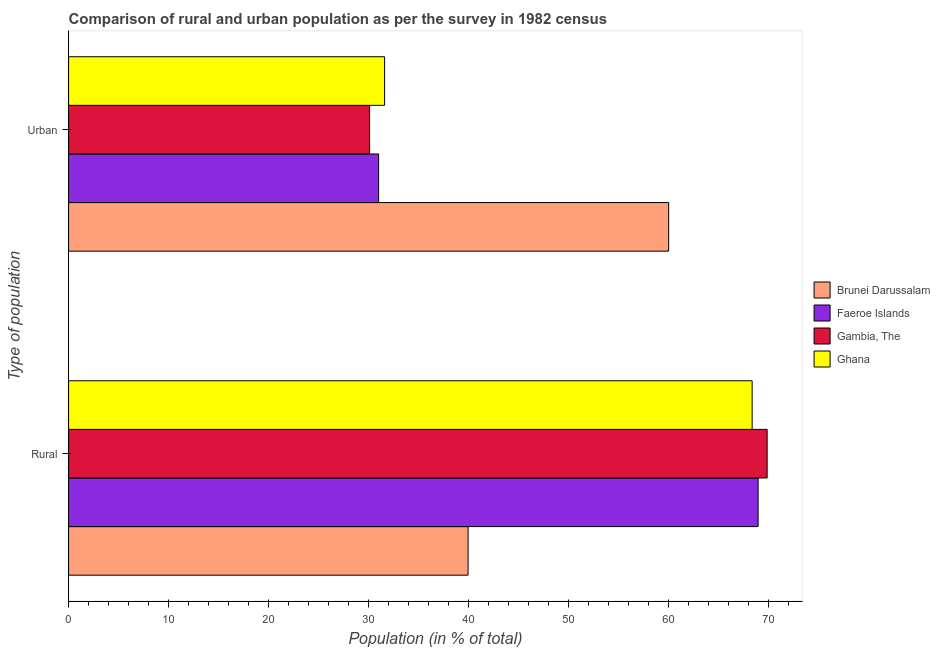Are the number of bars per tick equal to the number of legend labels?
Your answer should be very brief. Yes. Are the number of bars on each tick of the Y-axis equal?
Make the answer very short. Yes. What is the label of the 1st group of bars from the top?
Ensure brevity in your answer.  Urban. What is the urban population in Brunei Darussalam?
Ensure brevity in your answer.  60.03. Across all countries, what is the maximum urban population?
Provide a succinct answer. 60.03. Across all countries, what is the minimum rural population?
Ensure brevity in your answer.  39.97. In which country was the rural population maximum?
Give a very brief answer. Gambia, The. In which country was the rural population minimum?
Your answer should be very brief. Brunei Darussalam. What is the total urban population in the graph?
Give a very brief answer. 152.78. What is the difference between the rural population in Brunei Darussalam and that in Ghana?
Offer a terse response. -28.42. What is the difference between the rural population in Brunei Darussalam and the urban population in Gambia, The?
Your answer should be very brief. 9.85. What is the average rural population per country?
Provide a succinct answer. 61.81. What is the difference between the rural population and urban population in Faeroe Islands?
Provide a short and direct response. 37.97. What is the ratio of the rural population in Faeroe Islands to that in Gambia, The?
Provide a short and direct response. 0.99. Is the urban population in Gambia, The less than that in Faeroe Islands?
Offer a terse response. Yes. In how many countries, is the rural population greater than the average rural population taken over all countries?
Ensure brevity in your answer.  3. What does the 2nd bar from the top in Rural represents?
Keep it short and to the point. Gambia, The. What does the 2nd bar from the bottom in Urban represents?
Give a very brief answer. Faeroe Islands. How many bars are there?
Ensure brevity in your answer.  8. What is the difference between two consecutive major ticks on the X-axis?
Offer a very short reply. 10. Does the graph contain grids?
Make the answer very short. No. How many legend labels are there?
Your answer should be very brief. 4. How are the legend labels stacked?
Your answer should be very brief. Vertical. What is the title of the graph?
Ensure brevity in your answer.  Comparison of rural and urban population as per the survey in 1982 census. Does "Sri Lanka" appear as one of the legend labels in the graph?
Make the answer very short. No. What is the label or title of the X-axis?
Give a very brief answer. Population (in % of total). What is the label or title of the Y-axis?
Ensure brevity in your answer.  Type of population. What is the Population (in % of total) in Brunei Darussalam in Rural?
Provide a succinct answer. 39.97. What is the Population (in % of total) of Faeroe Islands in Rural?
Make the answer very short. 68.98. What is the Population (in % of total) of Gambia, The in Rural?
Offer a terse response. 69.89. What is the Population (in % of total) of Ghana in Rural?
Offer a terse response. 68.39. What is the Population (in % of total) in Brunei Darussalam in Urban?
Your answer should be compact. 60.03. What is the Population (in % of total) in Faeroe Islands in Urban?
Your answer should be very brief. 31.02. What is the Population (in % of total) of Gambia, The in Urban?
Your answer should be compact. 30.11. What is the Population (in % of total) in Ghana in Urban?
Offer a very short reply. 31.61. Across all Type of population, what is the maximum Population (in % of total) of Brunei Darussalam?
Offer a very short reply. 60.03. Across all Type of population, what is the maximum Population (in % of total) in Faeroe Islands?
Make the answer very short. 68.98. Across all Type of population, what is the maximum Population (in % of total) in Gambia, The?
Offer a very short reply. 69.89. Across all Type of population, what is the maximum Population (in % of total) of Ghana?
Your response must be concise. 68.39. Across all Type of population, what is the minimum Population (in % of total) in Brunei Darussalam?
Provide a short and direct response. 39.97. Across all Type of population, what is the minimum Population (in % of total) in Faeroe Islands?
Ensure brevity in your answer.  31.02. Across all Type of population, what is the minimum Population (in % of total) in Gambia, The?
Your answer should be compact. 30.11. Across all Type of population, what is the minimum Population (in % of total) in Ghana?
Provide a succinct answer. 31.61. What is the difference between the Population (in % of total) in Brunei Darussalam in Rural and that in Urban?
Keep it short and to the point. -20.07. What is the difference between the Population (in % of total) of Faeroe Islands in Rural and that in Urban?
Offer a terse response. 37.97. What is the difference between the Population (in % of total) of Gambia, The in Rural and that in Urban?
Keep it short and to the point. 39.77. What is the difference between the Population (in % of total) of Ghana in Rural and that in Urban?
Give a very brief answer. 36.77. What is the difference between the Population (in % of total) in Brunei Darussalam in Rural and the Population (in % of total) in Faeroe Islands in Urban?
Ensure brevity in your answer.  8.95. What is the difference between the Population (in % of total) of Brunei Darussalam in Rural and the Population (in % of total) of Gambia, The in Urban?
Your response must be concise. 9.85. What is the difference between the Population (in % of total) in Brunei Darussalam in Rural and the Population (in % of total) in Ghana in Urban?
Keep it short and to the point. 8.35. What is the difference between the Population (in % of total) in Faeroe Islands in Rural and the Population (in % of total) in Gambia, The in Urban?
Give a very brief answer. 38.87. What is the difference between the Population (in % of total) in Faeroe Islands in Rural and the Population (in % of total) in Ghana in Urban?
Offer a terse response. 37.37. What is the difference between the Population (in % of total) in Gambia, The in Rural and the Population (in % of total) in Ghana in Urban?
Your response must be concise. 38.27. What is the average Population (in % of total) of Faeroe Islands per Type of population?
Ensure brevity in your answer.  50. What is the average Population (in % of total) in Ghana per Type of population?
Your response must be concise. 50. What is the difference between the Population (in % of total) in Brunei Darussalam and Population (in % of total) in Faeroe Islands in Rural?
Give a very brief answer. -29.02. What is the difference between the Population (in % of total) in Brunei Darussalam and Population (in % of total) in Gambia, The in Rural?
Keep it short and to the point. -29.92. What is the difference between the Population (in % of total) of Brunei Darussalam and Population (in % of total) of Ghana in Rural?
Give a very brief answer. -28.42. What is the difference between the Population (in % of total) of Faeroe Islands and Population (in % of total) of Gambia, The in Rural?
Ensure brevity in your answer.  -0.9. What is the difference between the Population (in % of total) of Faeroe Islands and Population (in % of total) of Ghana in Rural?
Keep it short and to the point. 0.6. What is the difference between the Population (in % of total) in Gambia, The and Population (in % of total) in Ghana in Rural?
Offer a terse response. 1.5. What is the difference between the Population (in % of total) in Brunei Darussalam and Population (in % of total) in Faeroe Islands in Urban?
Offer a terse response. 29.02. What is the difference between the Population (in % of total) in Brunei Darussalam and Population (in % of total) in Gambia, The in Urban?
Keep it short and to the point. 29.92. What is the difference between the Population (in % of total) of Brunei Darussalam and Population (in % of total) of Ghana in Urban?
Your response must be concise. 28.42. What is the difference between the Population (in % of total) of Faeroe Islands and Population (in % of total) of Gambia, The in Urban?
Make the answer very short. 0.9. What is the difference between the Population (in % of total) in Faeroe Islands and Population (in % of total) in Ghana in Urban?
Provide a short and direct response. -0.6. What is the difference between the Population (in % of total) in Gambia, The and Population (in % of total) in Ghana in Urban?
Give a very brief answer. -1.5. What is the ratio of the Population (in % of total) in Brunei Darussalam in Rural to that in Urban?
Your answer should be very brief. 0.67. What is the ratio of the Population (in % of total) of Faeroe Islands in Rural to that in Urban?
Your answer should be compact. 2.22. What is the ratio of the Population (in % of total) of Gambia, The in Rural to that in Urban?
Your response must be concise. 2.32. What is the ratio of the Population (in % of total) in Ghana in Rural to that in Urban?
Offer a terse response. 2.16. What is the difference between the highest and the second highest Population (in % of total) of Brunei Darussalam?
Offer a terse response. 20.07. What is the difference between the highest and the second highest Population (in % of total) of Faeroe Islands?
Your answer should be very brief. 37.97. What is the difference between the highest and the second highest Population (in % of total) in Gambia, The?
Provide a short and direct response. 39.77. What is the difference between the highest and the second highest Population (in % of total) of Ghana?
Provide a succinct answer. 36.77. What is the difference between the highest and the lowest Population (in % of total) of Brunei Darussalam?
Your response must be concise. 20.07. What is the difference between the highest and the lowest Population (in % of total) in Faeroe Islands?
Your response must be concise. 37.97. What is the difference between the highest and the lowest Population (in % of total) of Gambia, The?
Offer a terse response. 39.77. What is the difference between the highest and the lowest Population (in % of total) of Ghana?
Make the answer very short. 36.77. 